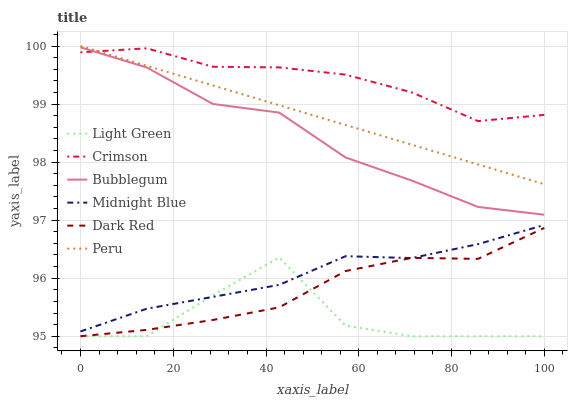Does Light Green have the minimum area under the curve?
Answer yes or no. Yes. Does Crimson have the maximum area under the curve?
Answer yes or no. Yes. Does Dark Red have the minimum area under the curve?
Answer yes or no. No. Does Dark Red have the maximum area under the curve?
Answer yes or no. No. Is Peru the smoothest?
Answer yes or no. Yes. Is Light Green the roughest?
Answer yes or no. Yes. Is Dark Red the smoothest?
Answer yes or no. No. Is Dark Red the roughest?
Answer yes or no. No. Does Light Green have the lowest value?
Answer yes or no. Yes. Does Bubblegum have the lowest value?
Answer yes or no. No. Does Peru have the highest value?
Answer yes or no. Yes. Does Dark Red have the highest value?
Answer yes or no. No. Is Dark Red less than Peru?
Answer yes or no. Yes. Is Peru greater than Midnight Blue?
Answer yes or no. Yes. Does Crimson intersect Peru?
Answer yes or no. Yes. Is Crimson less than Peru?
Answer yes or no. No. Is Crimson greater than Peru?
Answer yes or no. No. Does Dark Red intersect Peru?
Answer yes or no. No. 